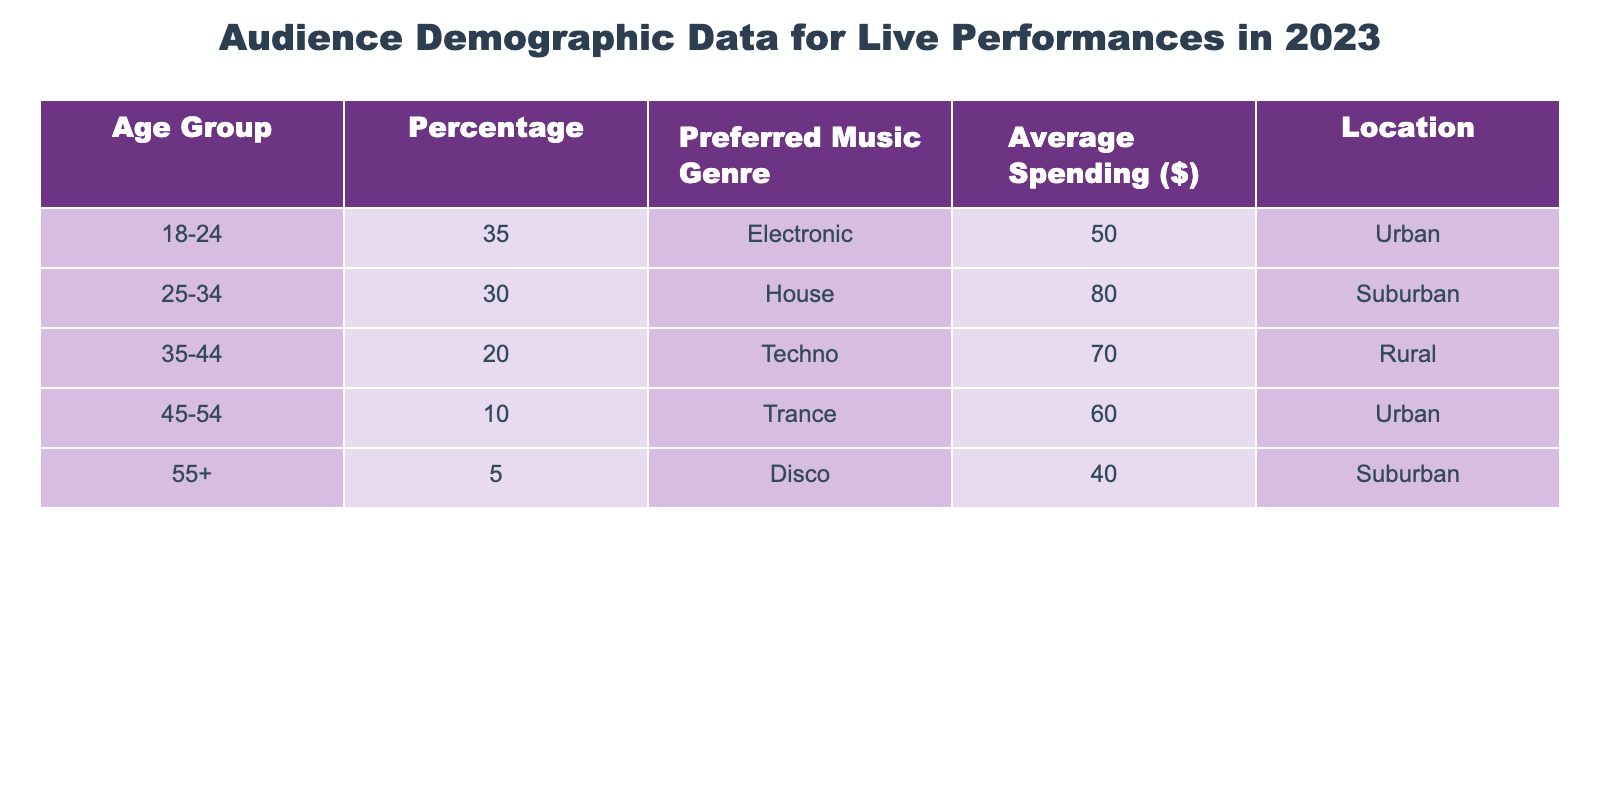What percentage of the audience is aged 25-34? According to the table, the percentage of the audience in the 25-34 age group is listed directly in the "Percentage" column corresponding to that age group. It shows 30%.
Answer: 30% Which music genre is preferred by the oldest age group? The oldest age group listed is 55+, and looking at the "Preferred Music Genre" column for that age group, we find that Disco is the preferred genre.
Answer: Disco What is the average spending of the 18-24 age group compared to the 45-54 age group? The average spending for the 18-24 age group is $50, and for the 45-54 age group, it is $60. To compare, $50 is less than $60.
Answer: $50 is less than $60 Is the preferred music genre for the 35-44 age group Techno? According to the "Preferred Music Genre" column, the preferred genre for the 35-44 age group is indeed listed as Techno.
Answer: Yes If we sum the average spending of all age groups, what is the total? The average spending amounts are $50, $80, $70, $60, and $40. Adding these amounts together gives $50 + $80 + $70 + $60 + $40 = $300. Therefore, the total average spending across all age groups is $300.
Answer: $300 What percentage of the audience prefers Electronic music over Techno? The percentage that prefers Electronic music (18-24 age group) is 35%, while the percentage that prefers Techno (35-44 age group) is 20%. To find out how many prefer Electronic over Techno, we can compare these two figures: 35% is greater than 20%.
Answer: 35% is greater than 20% What location has the highest average spending according to the table? By examining the "Average Spending" column, we see that the 25-34 age group, who live in Suburban areas, spends the most at $80. Therefore, Suburban is the location with the highest average spending.
Answer: Suburban Is the majority of the audience located in Urban areas? The data shows that both the 18-24 and 45-54 age groups are located in Urban areas, making a total of two Urban locations. While the 25-34 age group is in Suburban, and the 35-44 in Rural, the information does not suggest that Urban areas house a majority since there are only two groups when compared to three others total.
Answer: No How does the average spending of the Rural audience (35-44 group) compare to that of the Urban audience (45-54 group)? The 35-44 age group in Rural areas averages spending $70, while the 45-54 age group in Urban areas spends $60. Therefore, comparing these two reveals that the Rural audience spends more on average than the Urban audience in this case.
Answer: Rural audience spends more 